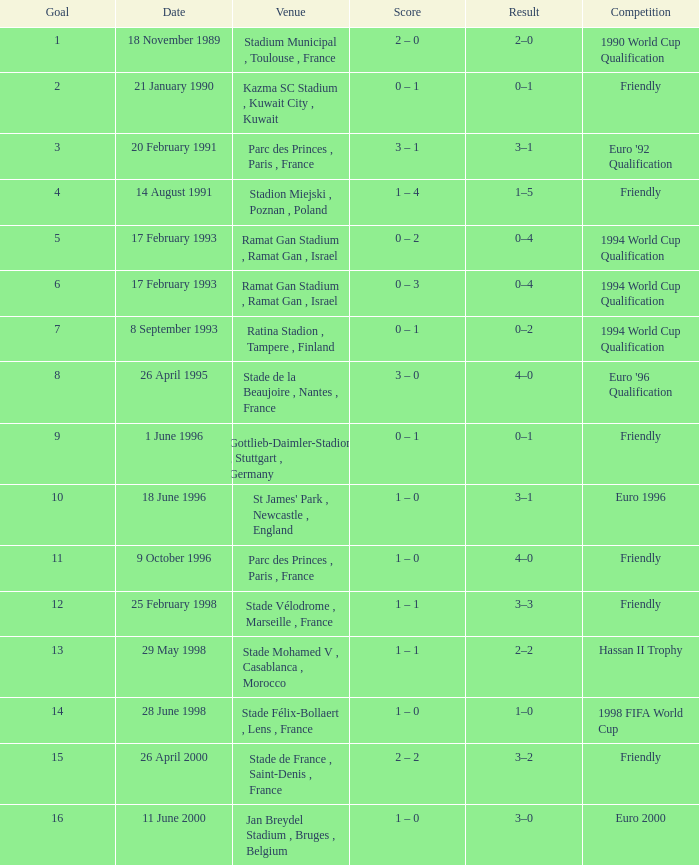On which date did the game with a 3-2 outcome take place? 26 April 2000. I'm looking to parse the entire table for insights. Could you assist me with that? {'header': ['Goal', 'Date', 'Venue', 'Score', 'Result', 'Competition'], 'rows': [['1', '18 November 1989', 'Stadium Municipal , Toulouse , France', '2 – 0', '2–0', '1990 World Cup Qualification'], ['2', '21 January 1990', 'Kazma SC Stadium , Kuwait City , Kuwait', '0 – 1', '0–1', 'Friendly'], ['3', '20 February 1991', 'Parc des Princes , Paris , France', '3 – 1', '3–1', "Euro '92 Qualification"], ['4', '14 August 1991', 'Stadion Miejski , Poznan , Poland', '1 – 4', '1–5', 'Friendly'], ['5', '17 February 1993', 'Ramat Gan Stadium , Ramat Gan , Israel', '0 – 2', '0–4', '1994 World Cup Qualification'], ['6', '17 February 1993', 'Ramat Gan Stadium , Ramat Gan , Israel', '0 – 3', '0–4', '1994 World Cup Qualification'], ['7', '8 September 1993', 'Ratina Stadion , Tampere , Finland', '0 – 1', '0–2', '1994 World Cup Qualification'], ['8', '26 April 1995', 'Stade de la Beaujoire , Nantes , France', '3 – 0', '4–0', "Euro '96 Qualification"], ['9', '1 June 1996', 'Gottlieb-Daimler-Stadion , Stuttgart , Germany', '0 – 1', '0–1', 'Friendly'], ['10', '18 June 1996', "St James' Park , Newcastle , England", '1 – 0', '3–1', 'Euro 1996'], ['11', '9 October 1996', 'Parc des Princes , Paris , France', '1 – 0', '4–0', 'Friendly'], ['12', '25 February 1998', 'Stade Vélodrome , Marseille , France', '1 – 1', '3–3', 'Friendly'], ['13', '29 May 1998', 'Stade Mohamed V , Casablanca , Morocco', '1 – 1', '2–2', 'Hassan II Trophy'], ['14', '28 June 1998', 'Stade Félix-Bollaert , Lens , France', '1 – 0', '1–0', '1998 FIFA World Cup'], ['15', '26 April 2000', 'Stade de France , Saint-Denis , France', '2 – 2', '3–2', 'Friendly'], ['16', '11 June 2000', 'Jan Breydel Stadium , Bruges , Belgium', '1 – 0', '3–0', 'Euro 2000']]} 